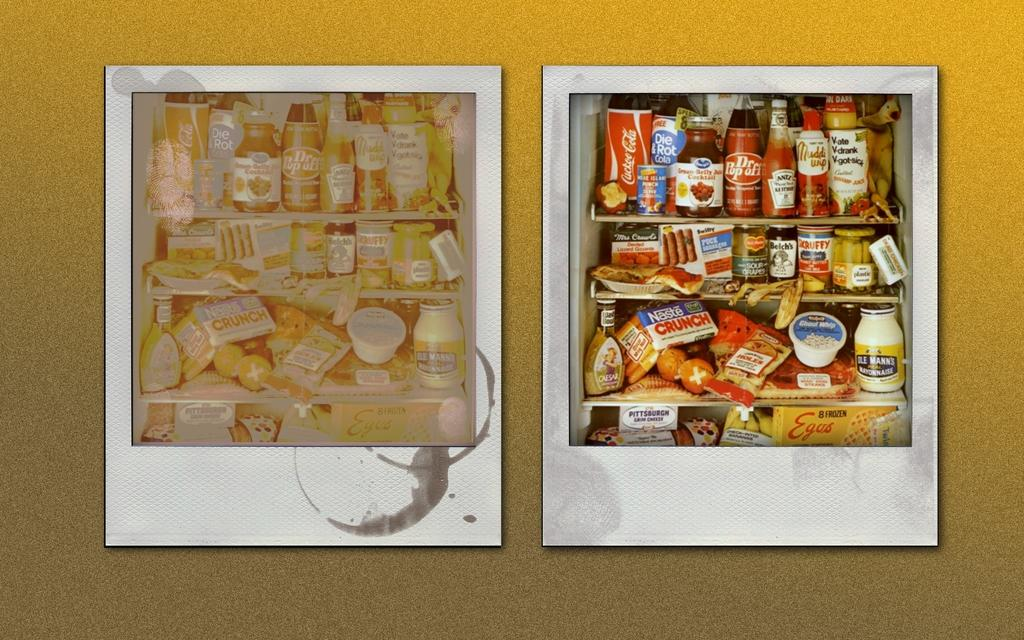<image>
Share a concise interpretation of the image provided. Two polaroid pictures side by side and one with a Dr. Popoff bottle. 